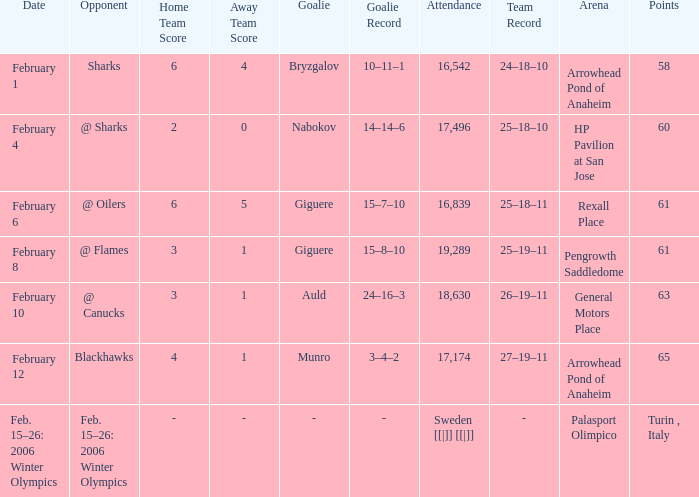What is the Arena when there were 65 points? Arrowhead Pond of Anaheim. 